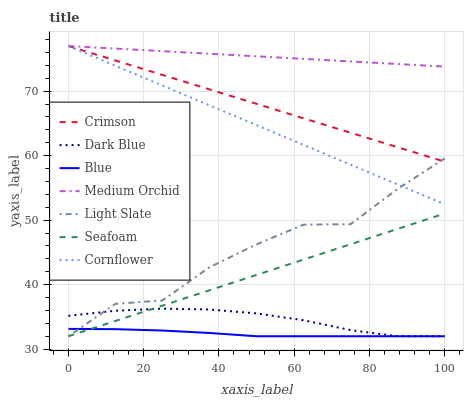Does Blue have the minimum area under the curve?
Answer yes or no. Yes. Does Medium Orchid have the maximum area under the curve?
Answer yes or no. Yes. Does Cornflower have the minimum area under the curve?
Answer yes or no. No. Does Cornflower have the maximum area under the curve?
Answer yes or no. No. Is Seafoam the smoothest?
Answer yes or no. Yes. Is Light Slate the roughest?
Answer yes or no. Yes. Is Cornflower the smoothest?
Answer yes or no. No. Is Cornflower the roughest?
Answer yes or no. No. Does Blue have the lowest value?
Answer yes or no. Yes. Does Cornflower have the lowest value?
Answer yes or no. No. Does Crimson have the highest value?
Answer yes or no. Yes. Does Light Slate have the highest value?
Answer yes or no. No. Is Blue less than Cornflower?
Answer yes or no. Yes. Is Medium Orchid greater than Dark Blue?
Answer yes or no. Yes. Does Cornflower intersect Light Slate?
Answer yes or no. Yes. Is Cornflower less than Light Slate?
Answer yes or no. No. Is Cornflower greater than Light Slate?
Answer yes or no. No. Does Blue intersect Cornflower?
Answer yes or no. No. 